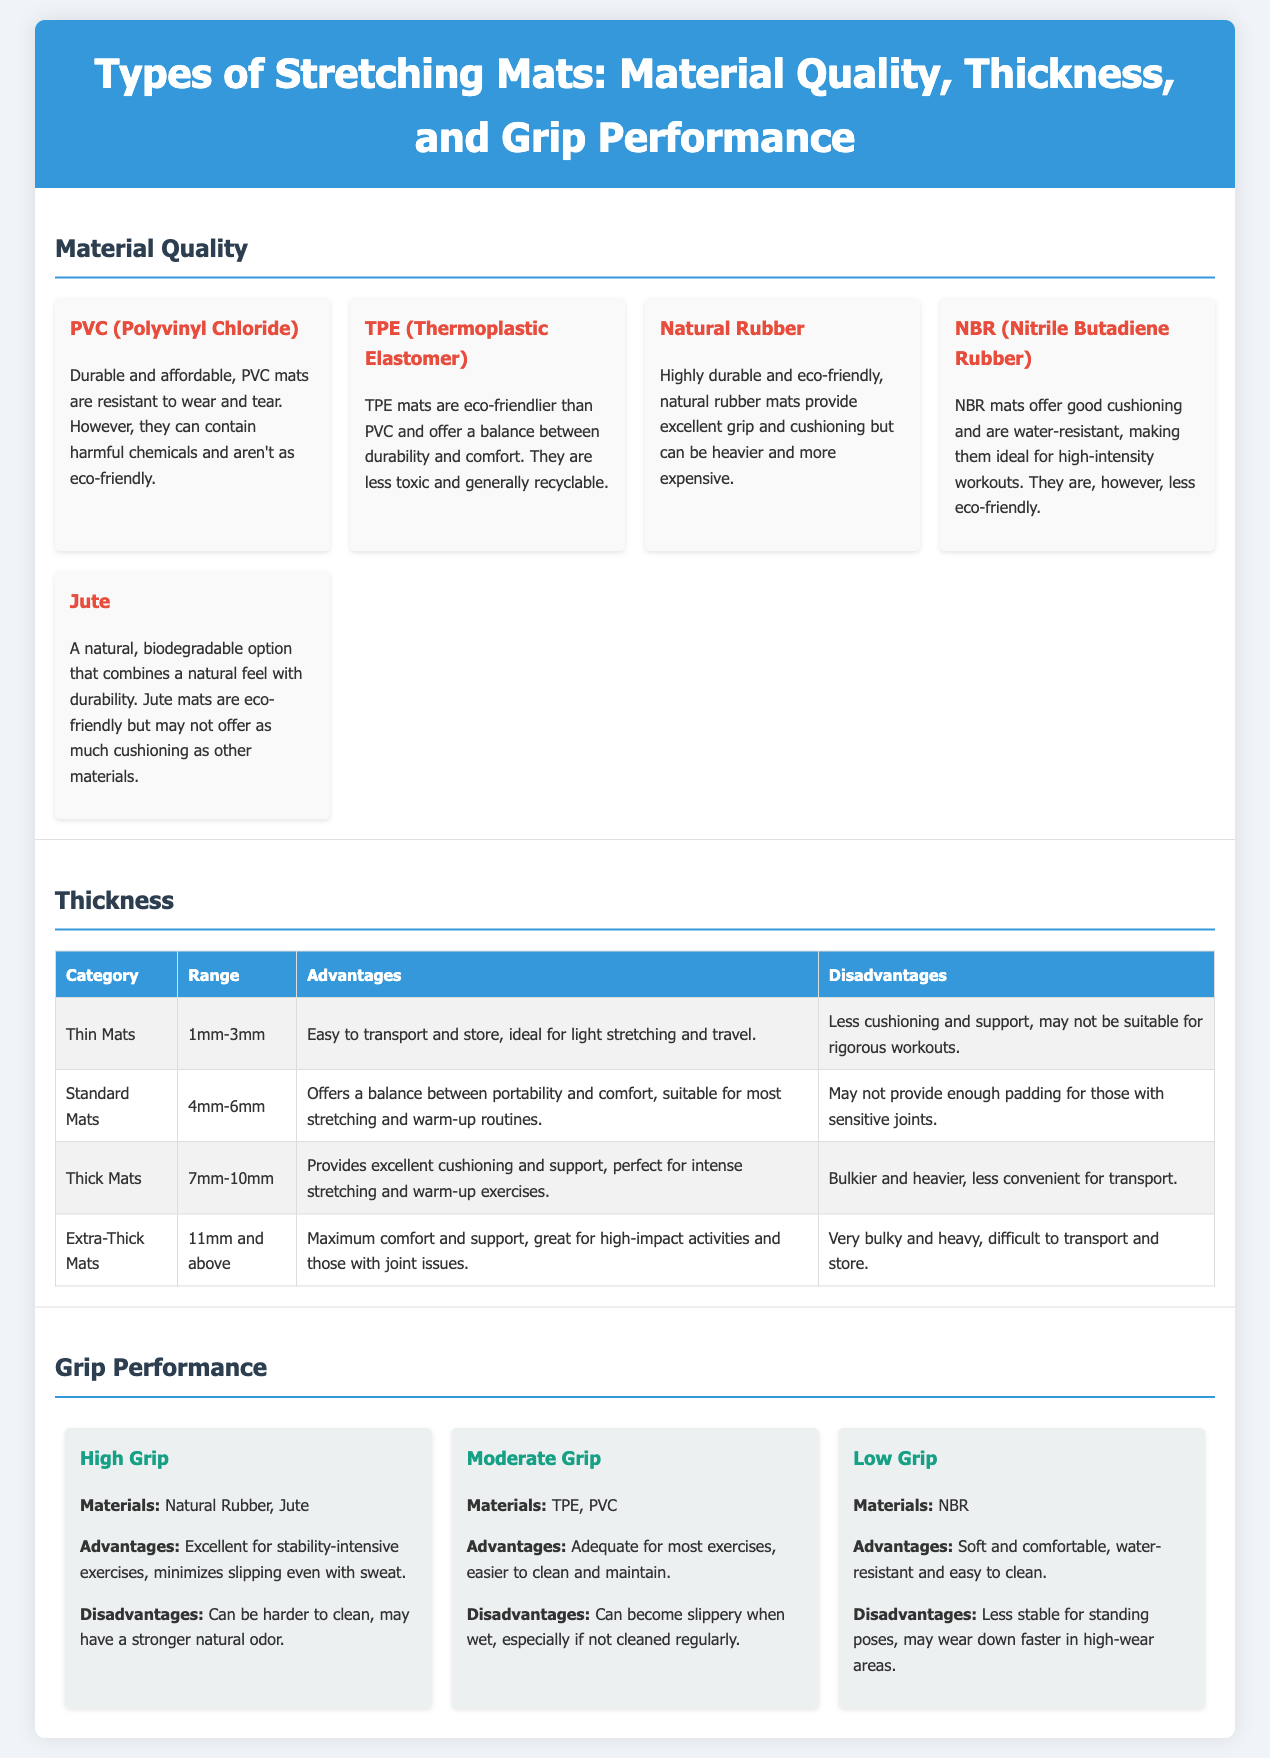what are the materials used in high grip mats? High grip mats are made from Natural Rubber and Jute, as stated in the grip performance section.
Answer: Natural Rubber, Jute what is the range of thickness for extra-thick mats? The thickness section indicates that extra-thick mats are 11mm and above.
Answer: 11mm and above what are the advantages of standard mats? The advantages of standard mats are listed as offering a balance between portability and comfort, suitable for most stretching and warm-up routines.
Answer: Balance between portability and comfort which material offers good cushioning and is water-resistant? The document states that NBR mats offer good cushioning and are water-resistant, specifically in the material quality section.
Answer: NBR what is a disadvantage of PVC mats? PVC mats are noted to contain harmful chemicals and aren't as eco-friendly, particularly in the material quality section.
Answer: Harmful chemicals which thick mat category provides maximum comfort and support? Extra-thick mats, stated in the thickness section, are characterized as providing maximum comfort and support.
Answer: Extra-thick mats how are TPE mats described in terms of eco-friendliness? The document describes TPE mats as eco-friendlier than PVC, which is mentioned in the material quality section.
Answer: Eco-friendlier than PVC what is the cushioning range for thick mats? The thickness section specifies that thick mats range from 7mm to 10mm in thickness.
Answer: 7mm-10mm 